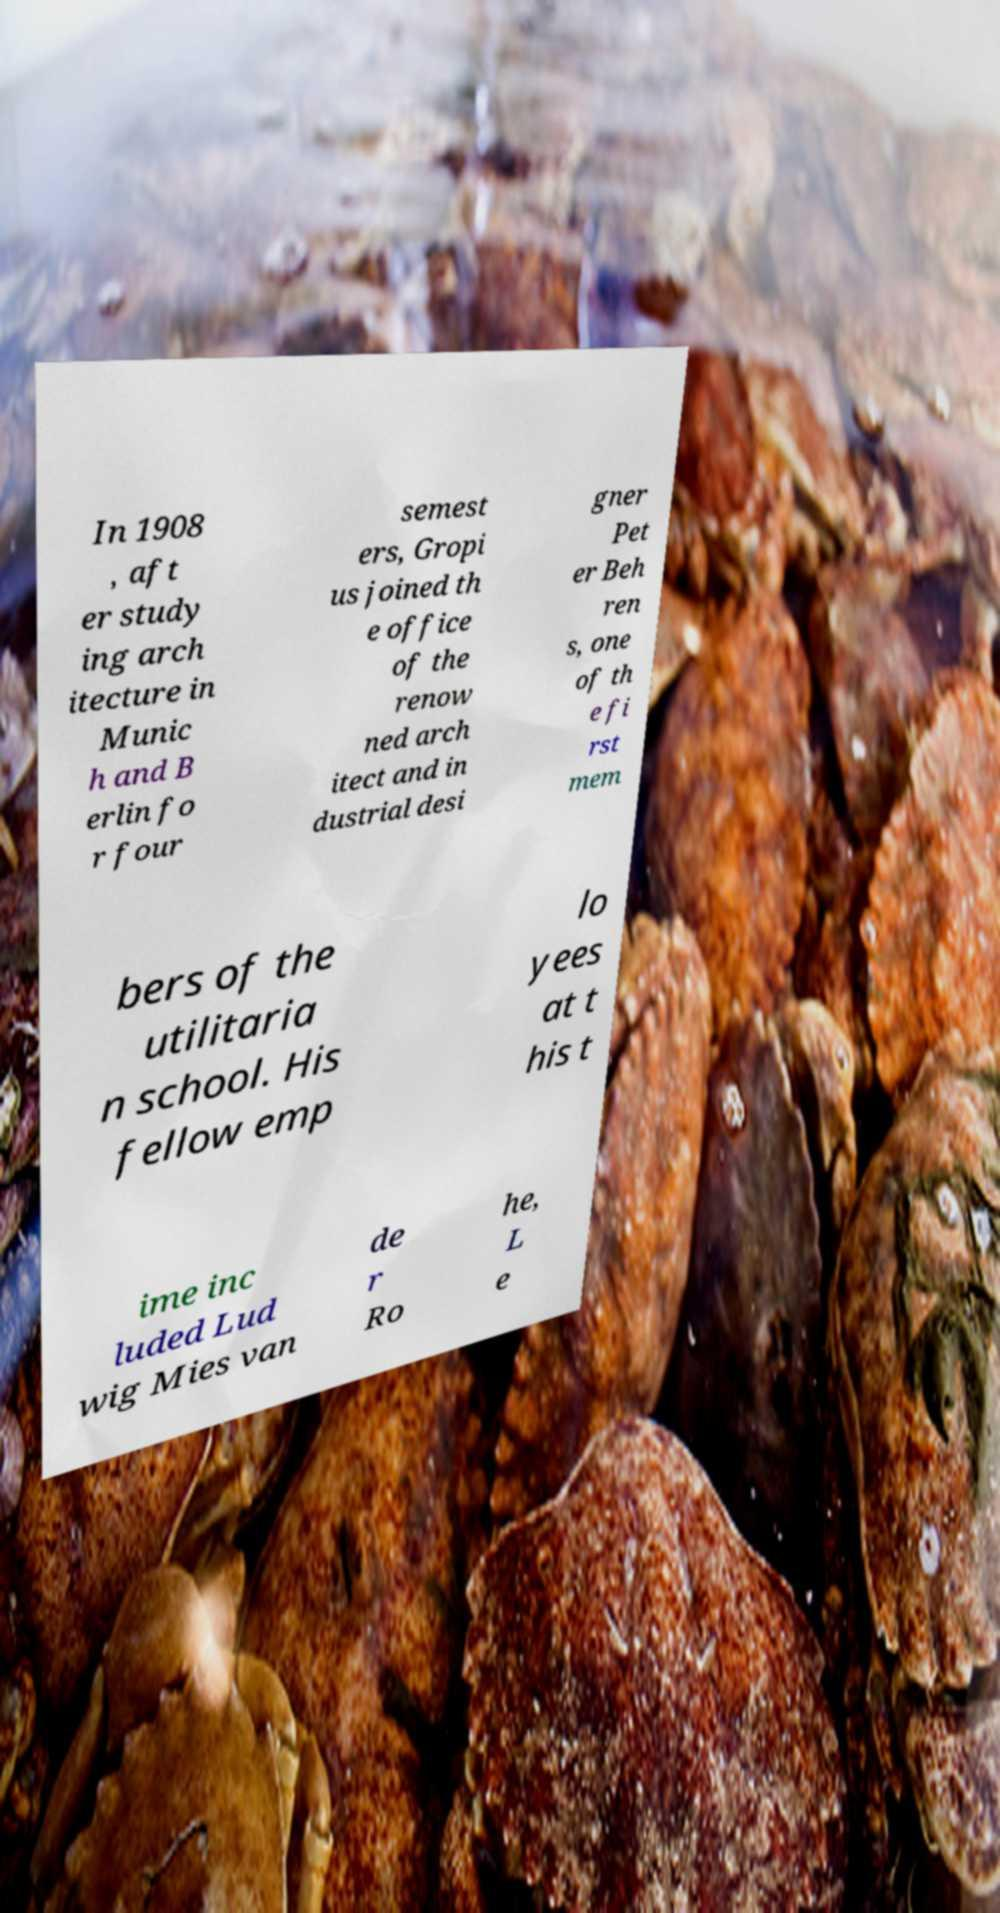What messages or text are displayed in this image? I need them in a readable, typed format. In 1908 , aft er study ing arch itecture in Munic h and B erlin fo r four semest ers, Gropi us joined th e office of the renow ned arch itect and in dustrial desi gner Pet er Beh ren s, one of th e fi rst mem bers of the utilitaria n school. His fellow emp lo yees at t his t ime inc luded Lud wig Mies van de r Ro he, L e 